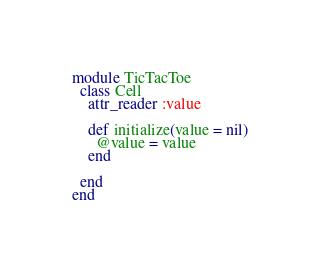Convert code to text. <code><loc_0><loc_0><loc_500><loc_500><_Ruby_>module TicTacToe
  class Cell
    attr_reader :value

    def initialize(value = nil)
      @value = value
    end

  end
end
</code> 